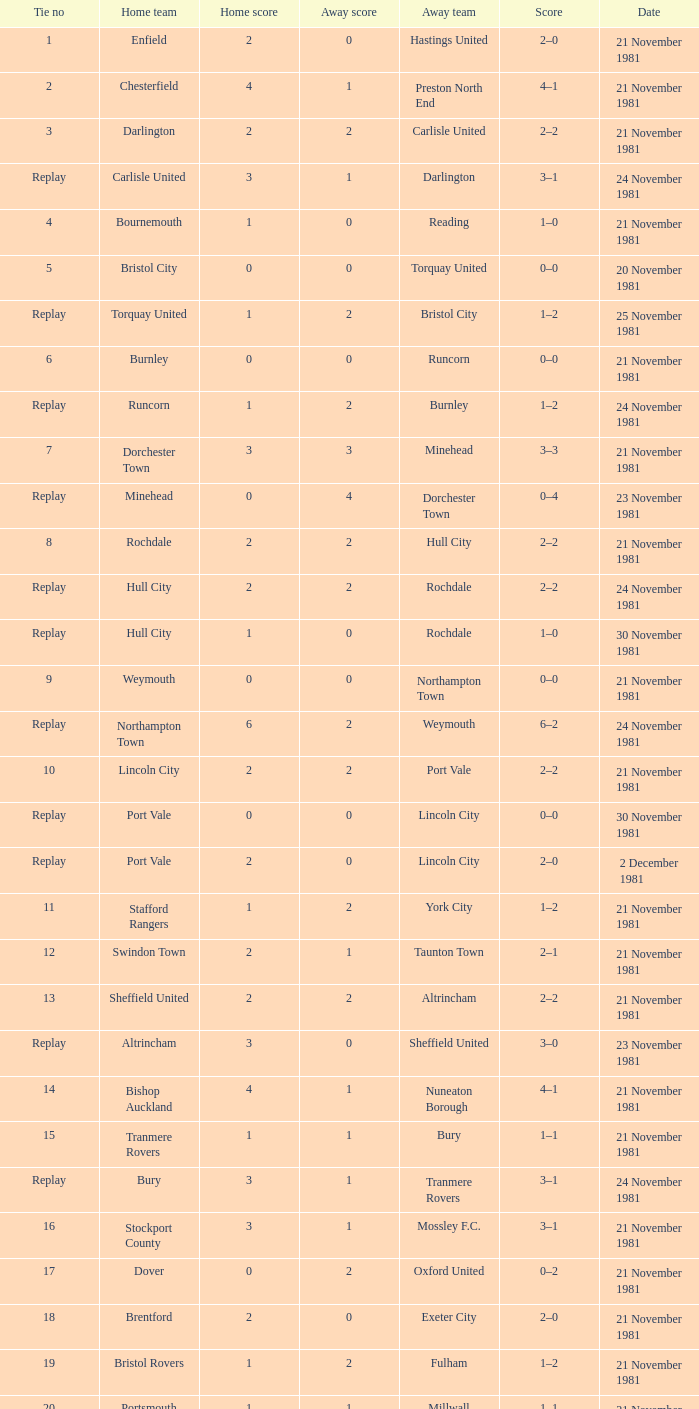What is minehead's tie figure? Replay. Can you give me this table as a dict? {'header': ['Tie no', 'Home team', 'Home score', 'Away score', 'Away team', 'Score', 'Date'], 'rows': [['1', 'Enfield', '2', '0', 'Hastings United', '2–0', '21 November 1981'], ['2', 'Chesterfield', '4', '1', 'Preston North End', '4–1', '21 November 1981'], ['3', 'Darlington', '2', '2', 'Carlisle United', '2–2', '21 November 1981'], ['Replay', 'Carlisle United', '3', '1', 'Darlington', '3–1', '24 November 1981'], ['4', 'Bournemouth', '1', '0', 'Reading', '1–0', '21 November 1981'], ['5', 'Bristol City', '0', '0', 'Torquay United', '0–0', '20 November 1981'], ['Replay', 'Torquay United', '1', '2', 'Bristol City', '1–2', '25 November 1981'], ['6', 'Burnley', '0', '0', 'Runcorn', '0–0', '21 November 1981'], ['Replay', 'Runcorn', '1', '2', 'Burnley', '1–2', '24 November 1981'], ['7', 'Dorchester Town', '3', '3', 'Minehead', '3–3', '21 November 1981'], ['Replay', 'Minehead', '0', '4', 'Dorchester Town', '0–4', '23 November 1981'], ['8', 'Rochdale', '2', '2', 'Hull City', '2–2', '21 November 1981'], ['Replay', 'Hull City', '2', '2', 'Rochdale', '2–2', '24 November 1981'], ['Replay', 'Hull City', '1', '0', 'Rochdale', '1–0', '30 November 1981'], ['9', 'Weymouth', '0', '0', 'Northampton Town', '0–0', '21 November 1981'], ['Replay', 'Northampton Town', '6', '2', 'Weymouth', '6–2', '24 November 1981'], ['10', 'Lincoln City', '2', '2', 'Port Vale', '2–2', '21 November 1981'], ['Replay', 'Port Vale', '0', '0', 'Lincoln City', '0–0', '30 November 1981'], ['Replay', 'Port Vale', '2', '0', 'Lincoln City', '2–0', '2 December 1981'], ['11', 'Stafford Rangers', '1', '2', 'York City', '1–2', '21 November 1981'], ['12', 'Swindon Town', '2', '1', 'Taunton Town', '2–1', '21 November 1981'], ['13', 'Sheffield United', '2', '2', 'Altrincham', '2–2', '21 November 1981'], ['Replay', 'Altrincham', '3', '0', 'Sheffield United', '3–0', '23 November 1981'], ['14', 'Bishop Auckland', '4', '1', 'Nuneaton Borough', '4–1', '21 November 1981'], ['15', 'Tranmere Rovers', '1', '1', 'Bury', '1–1', '21 November 1981'], ['Replay', 'Bury', '3', '1', 'Tranmere Rovers', '3–1', '24 November 1981'], ['16', 'Stockport County', '3', '1', 'Mossley F.C.', '3–1', '21 November 1981'], ['17', 'Dover', '0', '2', 'Oxford United', '0–2', '21 November 1981'], ['18', 'Brentford', '2', '0', 'Exeter City', '2–0', '21 November 1981'], ['19', 'Bristol Rovers', '1', '2', 'Fulham', '1–2', '21 November 1981'], ['20', 'Portsmouth', '1', '1', 'Millwall', '1–1', '21 November 1981'], ['Replay', 'Millwall', '3', '2', 'Portsmouth', '3–2', '25 November 1981'], ['21', 'Plymouth Argyle', '0', '0', 'Gillingham', '0–0', '21 November 1981'], ['Replay', 'Gillingham', '1', '0', 'Plymouth Argyle', '1–0', '24 November 1981'], ['22', 'Penrith', '1', '0', 'Chester', '1–0', '21 November 1981'], ['23', 'Scunthorpe United', '1', '0', 'Bradford City', '1–0', '21 November 1981'], ['24', 'Blyth Spartans', '1', '2', 'Walsall', '1–2', '21 November 1981'], ['25', 'Bedford Town', '0', '2', 'Wimbledon', '0–2', '21 November 1981'], ['26', 'Mansfield Town', '0', '1', 'Doncaster Rovers', '0–1', '21 November 1981'], ['27', 'Halifax Town', '0', '3', 'Peterborough United', '0–3', '21 November 1981'], ['28', 'Workington', '1', '1', 'Huddersfield Town', '1–1', '21 November 1981'], ['Replay', 'Huddersfield Town', '5', '0', 'Workington', '5–0', '24 November 1981'], ['29', 'Hereford United', '3', '1', 'Southend United', '3–1', '21 November 1981'], ['30', "Bishop's Stortford", '2', '2', 'Sutton United', '2–2', '21 November 1981'], ['Replay', 'Sutton United', '2', '1', "Bishop's Stortford", '2–1', '24 November 1981'], ['31', 'Bideford', '1', '2', 'Barking', '1–2', '21 November 1981'], ['32', 'Aldershot', '2', '0', 'Leytonstone/Ilford', '2–0', '21 November 1981'], ['33', 'Horden CW', '0', '1', 'Blackpool', '0–1', '21 November 1981'], ['34', 'Wigan Athletic', '2', '2', 'Hartlepool United', '2–2', '21 November 1981'], ['Replay', 'Hartlepool United', '1', '0', 'Wigan Athletic', '1–0', '25 November 1981'], ['35', 'Boston United', '0', '1', 'Kettering Town', '0–1', '21 November 1981'], ['36', 'Harlow Town', '0', '0', 'Barnet', '0–0', '21 November 1981'], ['Replay', 'Barnet', '1', '0', 'Harlow Town', '1–0', '24 November 1981'], ['37', 'Colchester United', '2', '0', 'Newport County', '2–0', '21 November 1981'], ['38', 'Hendon', '1', '1', 'Wycombe Wanderers', '1–1', '21 November 1981'], ['Replay', 'Wycombe Wanderers', '2', '0', 'Hendon', '2–0', '24 November 1981'], ['39', 'Dagenham', '2', '2', 'Yeovil Town', '2–2', '21 November 1981'], ['Replay', 'Yeovil Town', '0', '1', 'Dagenham', '0–1', '25 November 1981'], ['40', 'Willenhall Town', '0', '1', 'Crewe Alexandra', '0–1', '21 November 1981']]} 